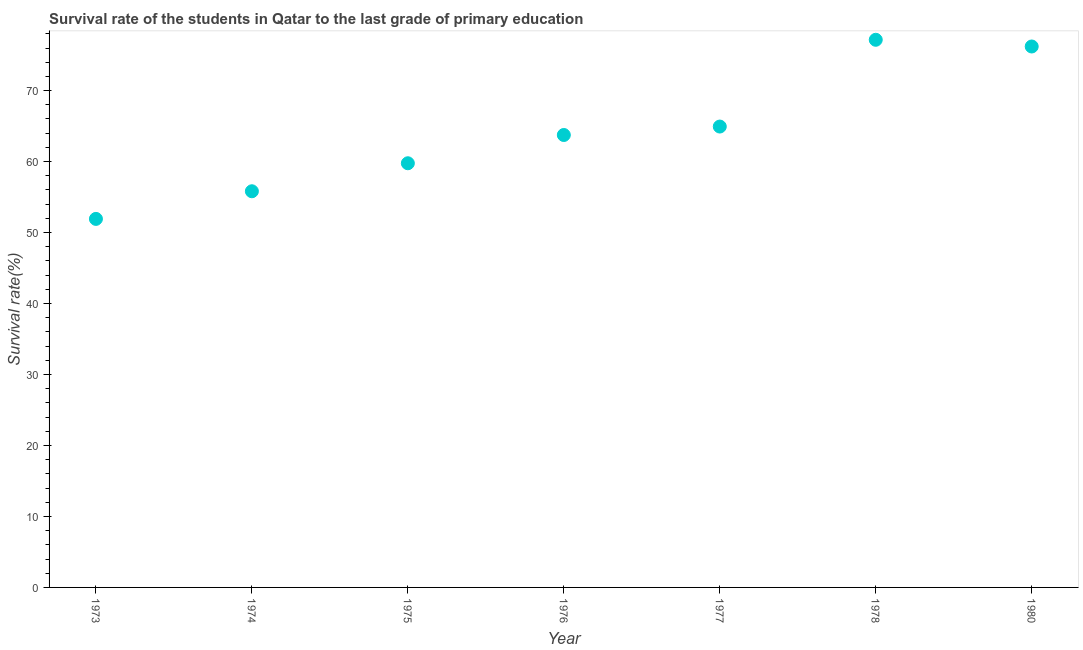What is the survival rate in primary education in 1978?
Ensure brevity in your answer.  77.16. Across all years, what is the maximum survival rate in primary education?
Your answer should be very brief. 77.16. Across all years, what is the minimum survival rate in primary education?
Your answer should be compact. 51.92. In which year was the survival rate in primary education maximum?
Your answer should be compact. 1978. What is the sum of the survival rate in primary education?
Your response must be concise. 449.56. What is the difference between the survival rate in primary education in 1977 and 1980?
Your answer should be compact. -11.28. What is the average survival rate in primary education per year?
Give a very brief answer. 64.22. What is the median survival rate in primary education?
Your answer should be very brief. 63.74. What is the ratio of the survival rate in primary education in 1974 to that in 1980?
Your answer should be compact. 0.73. What is the difference between the highest and the second highest survival rate in primary education?
Give a very brief answer. 0.95. Is the sum of the survival rate in primary education in 1975 and 1978 greater than the maximum survival rate in primary education across all years?
Ensure brevity in your answer.  Yes. What is the difference between the highest and the lowest survival rate in primary education?
Ensure brevity in your answer.  25.24. Does the survival rate in primary education monotonically increase over the years?
Make the answer very short. No. Are the values on the major ticks of Y-axis written in scientific E-notation?
Offer a very short reply. No. Does the graph contain any zero values?
Give a very brief answer. No. Does the graph contain grids?
Provide a short and direct response. No. What is the title of the graph?
Provide a short and direct response. Survival rate of the students in Qatar to the last grade of primary education. What is the label or title of the Y-axis?
Give a very brief answer. Survival rate(%). What is the Survival rate(%) in 1973?
Give a very brief answer. 51.92. What is the Survival rate(%) in 1974?
Ensure brevity in your answer.  55.82. What is the Survival rate(%) in 1975?
Make the answer very short. 59.76. What is the Survival rate(%) in 1976?
Make the answer very short. 63.74. What is the Survival rate(%) in 1977?
Offer a terse response. 64.93. What is the Survival rate(%) in 1978?
Offer a terse response. 77.16. What is the Survival rate(%) in 1980?
Make the answer very short. 76.21. What is the difference between the Survival rate(%) in 1973 and 1974?
Ensure brevity in your answer.  -3.89. What is the difference between the Survival rate(%) in 1973 and 1975?
Your response must be concise. -7.84. What is the difference between the Survival rate(%) in 1973 and 1976?
Offer a terse response. -11.82. What is the difference between the Survival rate(%) in 1973 and 1977?
Provide a short and direct response. -13.01. What is the difference between the Survival rate(%) in 1973 and 1978?
Your answer should be very brief. -25.24. What is the difference between the Survival rate(%) in 1973 and 1980?
Provide a short and direct response. -24.29. What is the difference between the Survival rate(%) in 1974 and 1975?
Offer a very short reply. -3.95. What is the difference between the Survival rate(%) in 1974 and 1976?
Offer a very short reply. -7.93. What is the difference between the Survival rate(%) in 1974 and 1977?
Keep it short and to the point. -9.12. What is the difference between the Survival rate(%) in 1974 and 1978?
Ensure brevity in your answer.  -21.34. What is the difference between the Survival rate(%) in 1974 and 1980?
Your answer should be very brief. -20.4. What is the difference between the Survival rate(%) in 1975 and 1976?
Provide a succinct answer. -3.98. What is the difference between the Survival rate(%) in 1975 and 1977?
Offer a terse response. -5.17. What is the difference between the Survival rate(%) in 1975 and 1978?
Your answer should be very brief. -17.4. What is the difference between the Survival rate(%) in 1975 and 1980?
Make the answer very short. -16.45. What is the difference between the Survival rate(%) in 1976 and 1977?
Offer a terse response. -1.19. What is the difference between the Survival rate(%) in 1976 and 1978?
Offer a terse response. -13.42. What is the difference between the Survival rate(%) in 1976 and 1980?
Provide a succinct answer. -12.47. What is the difference between the Survival rate(%) in 1977 and 1978?
Keep it short and to the point. -12.23. What is the difference between the Survival rate(%) in 1977 and 1980?
Your response must be concise. -11.28. What is the difference between the Survival rate(%) in 1978 and 1980?
Keep it short and to the point. 0.95. What is the ratio of the Survival rate(%) in 1973 to that in 1974?
Your answer should be very brief. 0.93. What is the ratio of the Survival rate(%) in 1973 to that in 1975?
Offer a very short reply. 0.87. What is the ratio of the Survival rate(%) in 1973 to that in 1976?
Your answer should be very brief. 0.81. What is the ratio of the Survival rate(%) in 1973 to that in 1977?
Your answer should be very brief. 0.8. What is the ratio of the Survival rate(%) in 1973 to that in 1978?
Keep it short and to the point. 0.67. What is the ratio of the Survival rate(%) in 1973 to that in 1980?
Give a very brief answer. 0.68. What is the ratio of the Survival rate(%) in 1974 to that in 1975?
Keep it short and to the point. 0.93. What is the ratio of the Survival rate(%) in 1974 to that in 1976?
Offer a terse response. 0.88. What is the ratio of the Survival rate(%) in 1974 to that in 1977?
Provide a succinct answer. 0.86. What is the ratio of the Survival rate(%) in 1974 to that in 1978?
Offer a very short reply. 0.72. What is the ratio of the Survival rate(%) in 1974 to that in 1980?
Offer a very short reply. 0.73. What is the ratio of the Survival rate(%) in 1975 to that in 1976?
Provide a succinct answer. 0.94. What is the ratio of the Survival rate(%) in 1975 to that in 1977?
Your answer should be very brief. 0.92. What is the ratio of the Survival rate(%) in 1975 to that in 1978?
Your answer should be compact. 0.78. What is the ratio of the Survival rate(%) in 1975 to that in 1980?
Your answer should be compact. 0.78. What is the ratio of the Survival rate(%) in 1976 to that in 1977?
Give a very brief answer. 0.98. What is the ratio of the Survival rate(%) in 1976 to that in 1978?
Provide a succinct answer. 0.83. What is the ratio of the Survival rate(%) in 1976 to that in 1980?
Provide a succinct answer. 0.84. What is the ratio of the Survival rate(%) in 1977 to that in 1978?
Provide a succinct answer. 0.84. What is the ratio of the Survival rate(%) in 1977 to that in 1980?
Your answer should be very brief. 0.85. What is the ratio of the Survival rate(%) in 1978 to that in 1980?
Your answer should be compact. 1.01. 